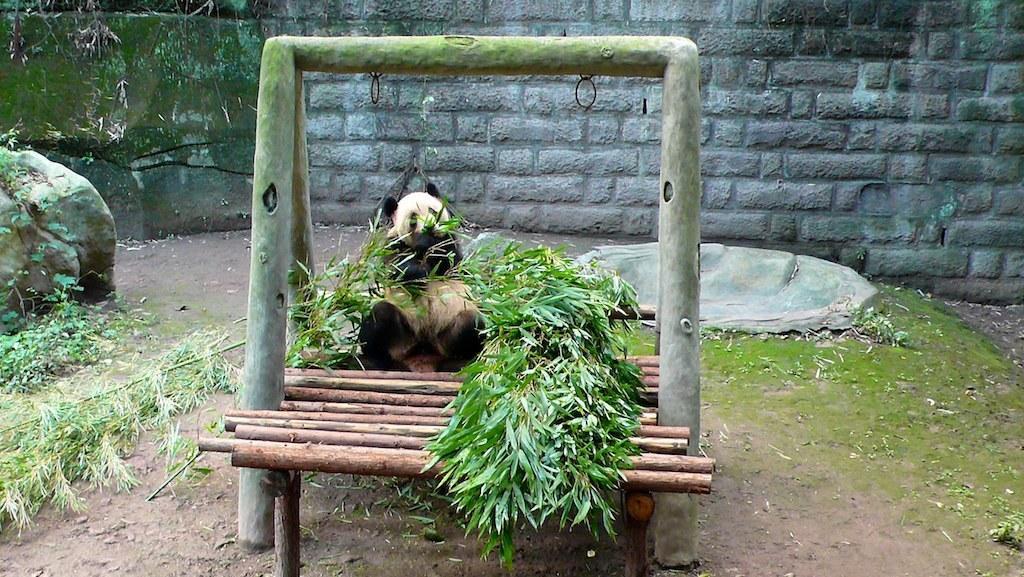Please provide a concise description of this image. In this picture there is a panda sitting on wooden platform and we can see stand, handles, leaves, stems, algae and rocks. In the background of the image we can see wall. 